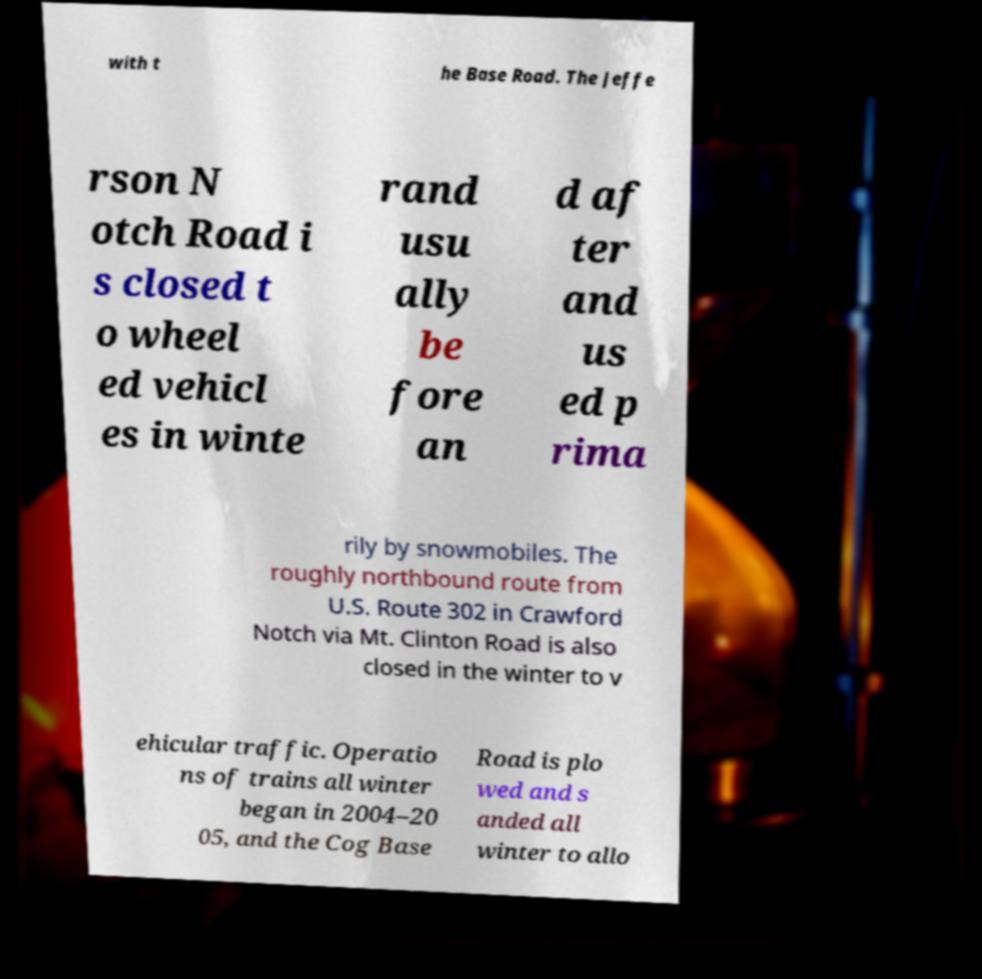Could you assist in decoding the text presented in this image and type it out clearly? with t he Base Road. The Jeffe rson N otch Road i s closed t o wheel ed vehicl es in winte rand usu ally be fore an d af ter and us ed p rima rily by snowmobiles. The roughly northbound route from U.S. Route 302 in Crawford Notch via Mt. Clinton Road is also closed in the winter to v ehicular traffic. Operatio ns of trains all winter began in 2004–20 05, and the Cog Base Road is plo wed and s anded all winter to allo 